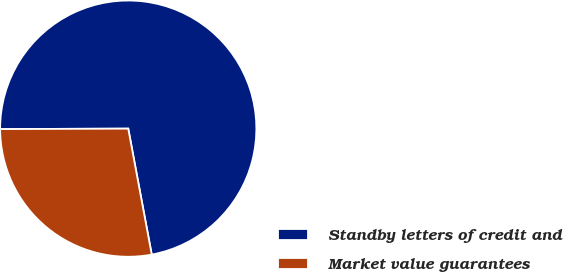Convert chart. <chart><loc_0><loc_0><loc_500><loc_500><pie_chart><fcel>Standby letters of credit and<fcel>Market value guarantees<nl><fcel>72.12%<fcel>27.88%<nl></chart> 